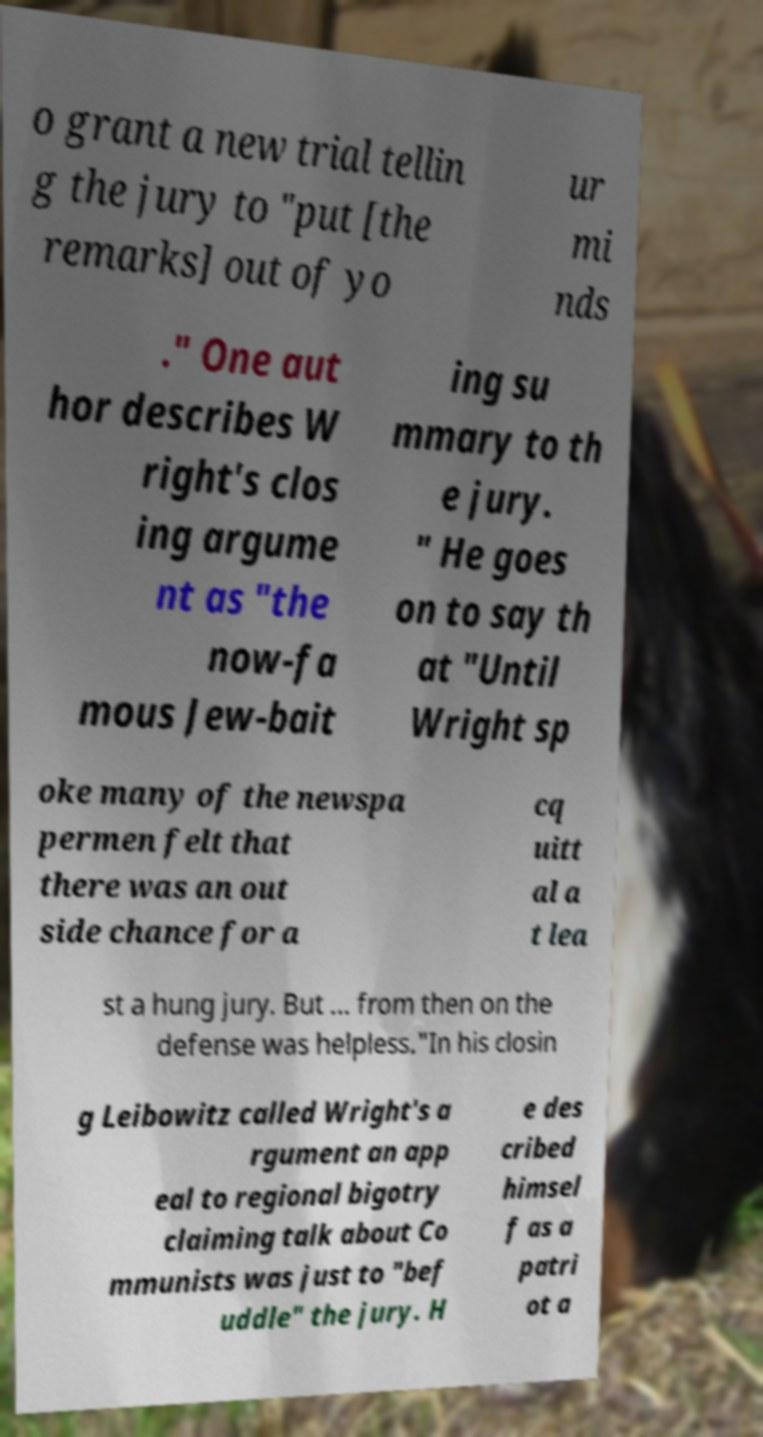Please read and relay the text visible in this image. What does it say? o grant a new trial tellin g the jury to "put [the remarks] out of yo ur mi nds ." One aut hor describes W right's clos ing argume nt as "the now-fa mous Jew-bait ing su mmary to th e jury. " He goes on to say th at "Until Wright sp oke many of the newspa permen felt that there was an out side chance for a cq uitt al a t lea st a hung jury. But ... from then on the defense was helpless."In his closin g Leibowitz called Wright's a rgument an app eal to regional bigotry claiming talk about Co mmunists was just to "bef uddle" the jury. H e des cribed himsel f as a patri ot a 